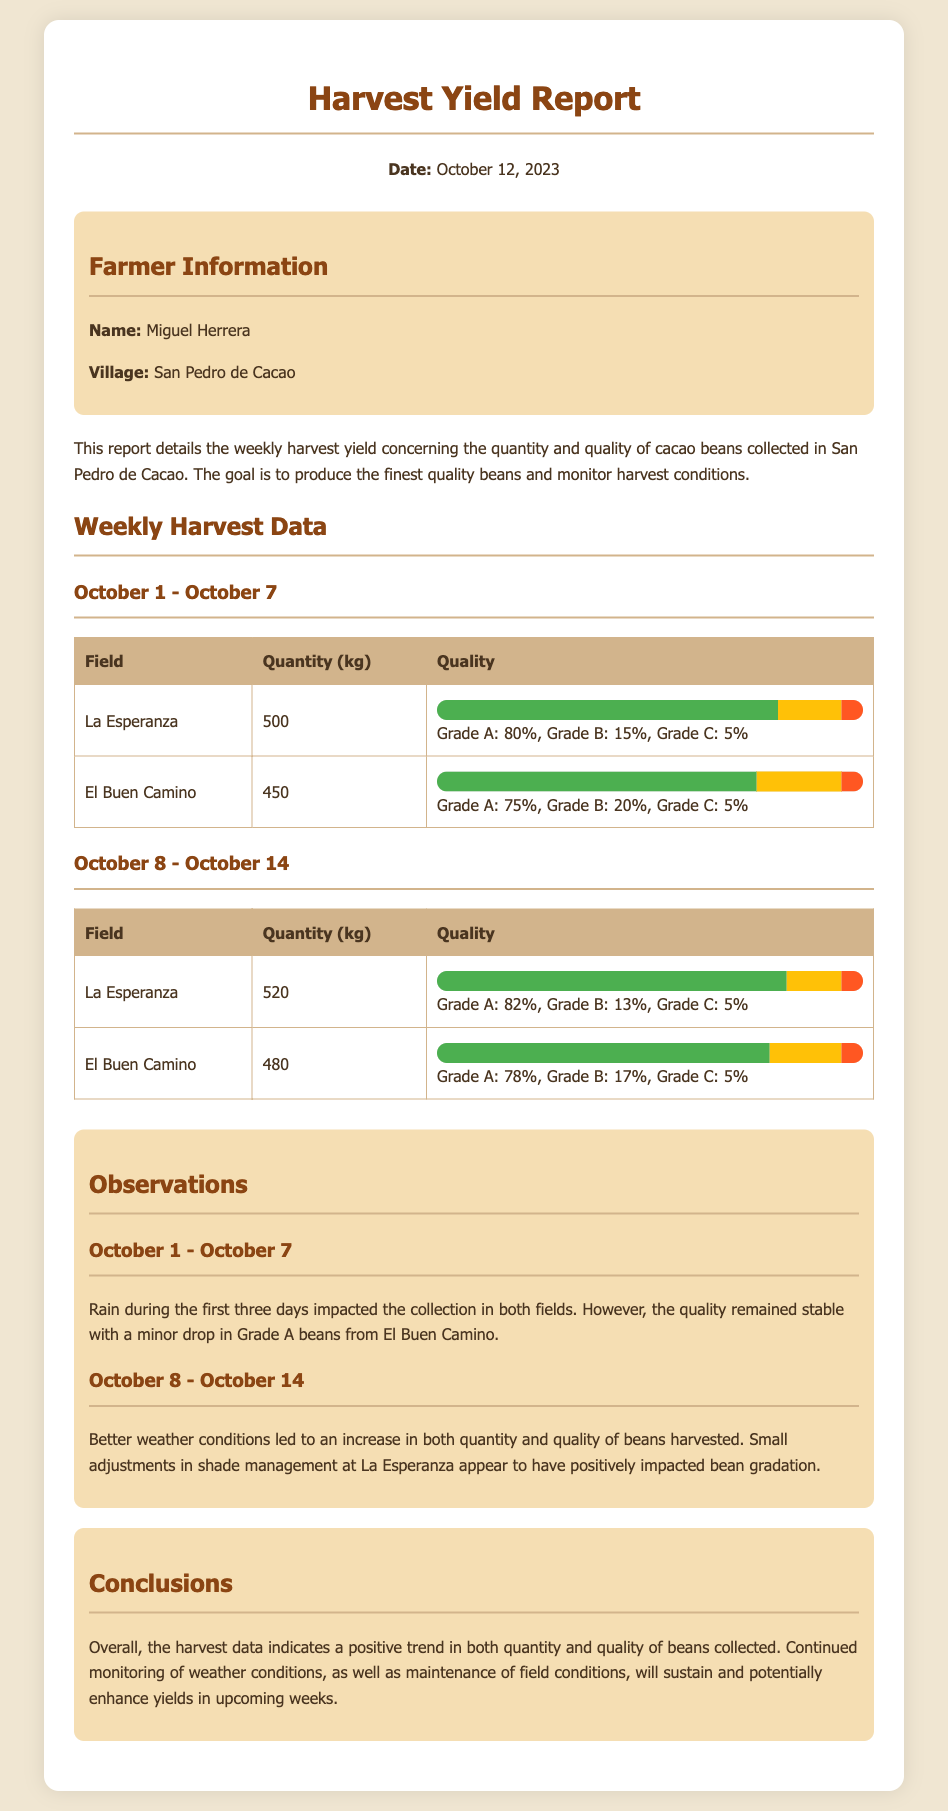What is the date of the report? The report is dated October 12, 2023.
Answer: October 12, 2023 Who is the farmer? The name of the farmer is mentioned in the farmer information section.
Answer: Miguel Herrera What was the quantity of beans harvested from La Esperanza from October 1 to October 7? The quantity harvested from La Esperanza is specified in the weekly harvest data table.
Answer: 500 kg What percentage of beans from El Buen Camino were Grade A during the second week? The percentage is indicated in the quality section of the data for El Buen Camino for October 8 to October 14.
Answer: 78% What impact did rain have during the first week? The observations in the report mention the effect of weather on the collection of beans.
Answer: Impacted collection How did the quantity of beans harvested change from the first week to the second week in La Esperanza? The quantities in the weekly data indicate a comparison between the two weeks.
Answer: Increased Which field benefited from shade management adjustments? The observations specifically note a field that had changes in shade management.
Answer: La Esperanza What is the overall conclusion about the harvest data? Conclusions are summarized in the conclusions section of the report.
Answer: Positive trend 